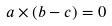Convert formula to latex. <formula><loc_0><loc_0><loc_500><loc_500>a \times ( b - c ) = 0</formula> 